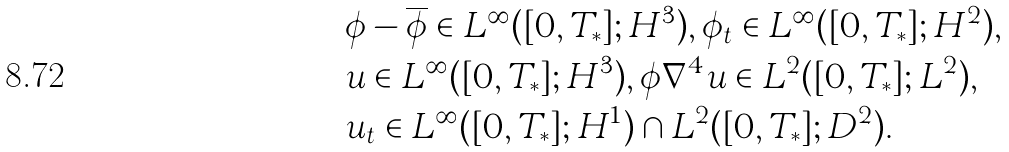Convert formula to latex. <formula><loc_0><loc_0><loc_500><loc_500>& \phi - \overline { \phi } \in L ^ { \infty } ( [ 0 , T _ { * } ] ; H ^ { 3 } ) , \phi _ { t } \in L ^ { \infty } ( [ 0 , T _ { * } ] ; H ^ { 2 } ) , \\ & u \in L ^ { \infty } ( [ 0 , T _ { * } ] ; H ^ { 3 } ) , \phi \nabla ^ { 4 } u \in L ^ { 2 } ( [ 0 , T _ { * } ] ; L ^ { 2 } ) , \\ & u _ { t } \in L ^ { \infty } ( [ 0 , T _ { * } ] ; H ^ { 1 } ) \cap L ^ { 2 } ( [ 0 , T _ { * } ] ; D ^ { 2 } ) .</formula> 